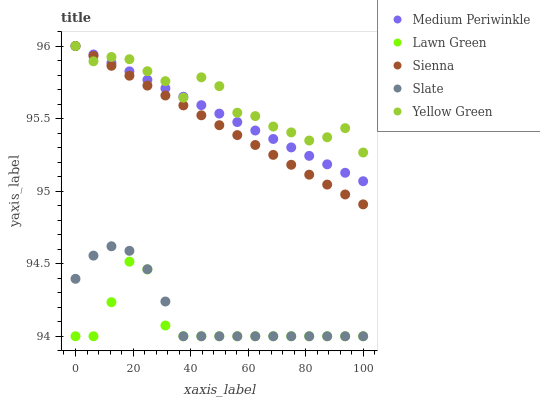Does Lawn Green have the minimum area under the curve?
Answer yes or no. Yes. Does Yellow Green have the maximum area under the curve?
Answer yes or no. Yes. Does Slate have the minimum area under the curve?
Answer yes or no. No. Does Slate have the maximum area under the curve?
Answer yes or no. No. Is Sienna the smoothest?
Answer yes or no. Yes. Is Yellow Green the roughest?
Answer yes or no. Yes. Is Lawn Green the smoothest?
Answer yes or no. No. Is Lawn Green the roughest?
Answer yes or no. No. Does Lawn Green have the lowest value?
Answer yes or no. Yes. Does Medium Periwinkle have the lowest value?
Answer yes or no. No. Does Yellow Green have the highest value?
Answer yes or no. Yes. Does Slate have the highest value?
Answer yes or no. No. Is Slate less than Medium Periwinkle?
Answer yes or no. Yes. Is Yellow Green greater than Slate?
Answer yes or no. Yes. Does Slate intersect Lawn Green?
Answer yes or no. Yes. Is Slate less than Lawn Green?
Answer yes or no. No. Is Slate greater than Lawn Green?
Answer yes or no. No. Does Slate intersect Medium Periwinkle?
Answer yes or no. No. 